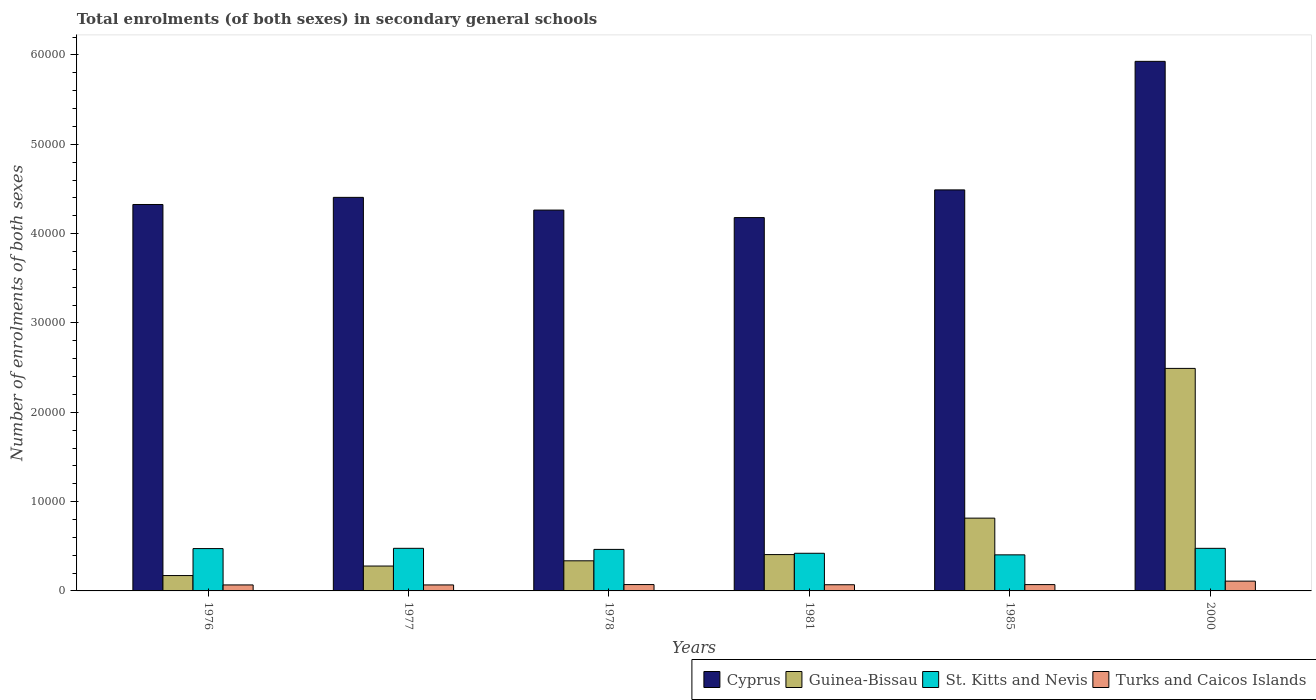How many different coloured bars are there?
Make the answer very short. 4. Are the number of bars per tick equal to the number of legend labels?
Offer a very short reply. Yes. What is the number of enrolments in secondary schools in Guinea-Bissau in 1978?
Make the answer very short. 3371. Across all years, what is the maximum number of enrolments in secondary schools in Turks and Caicos Islands?
Your answer should be very brief. 1095. Across all years, what is the minimum number of enrolments in secondary schools in Cyprus?
Offer a terse response. 4.18e+04. In which year was the number of enrolments in secondary schools in Guinea-Bissau maximum?
Your response must be concise. 2000. In which year was the number of enrolments in secondary schools in Guinea-Bissau minimum?
Provide a succinct answer. 1976. What is the total number of enrolments in secondary schools in Cyprus in the graph?
Offer a very short reply. 2.76e+05. What is the difference between the number of enrolments in secondary schools in St. Kitts and Nevis in 1981 and that in 1985?
Make the answer very short. 176. What is the difference between the number of enrolments in secondary schools in Turks and Caicos Islands in 1976 and the number of enrolments in secondary schools in Guinea-Bissau in 1978?
Make the answer very short. -2700. What is the average number of enrolments in secondary schools in St. Kitts and Nevis per year?
Ensure brevity in your answer.  4529.83. In the year 1977, what is the difference between the number of enrolments in secondary schools in Guinea-Bissau and number of enrolments in secondary schools in St. Kitts and Nevis?
Your answer should be very brief. -1985. What is the ratio of the number of enrolments in secondary schools in St. Kitts and Nevis in 1977 to that in 1981?
Your answer should be very brief. 1.13. What is the difference between the highest and the lowest number of enrolments in secondary schools in Turks and Caicos Islands?
Make the answer very short. 424. In how many years, is the number of enrolments in secondary schools in Guinea-Bissau greater than the average number of enrolments in secondary schools in Guinea-Bissau taken over all years?
Make the answer very short. 2. Is the sum of the number of enrolments in secondary schools in Turks and Caicos Islands in 1976 and 1977 greater than the maximum number of enrolments in secondary schools in St. Kitts and Nevis across all years?
Your answer should be compact. No. What does the 4th bar from the left in 1976 represents?
Your response must be concise. Turks and Caicos Islands. What does the 2nd bar from the right in 1978 represents?
Make the answer very short. St. Kitts and Nevis. What is the difference between two consecutive major ticks on the Y-axis?
Offer a terse response. 10000. Are the values on the major ticks of Y-axis written in scientific E-notation?
Give a very brief answer. No. Does the graph contain any zero values?
Offer a very short reply. No. Where does the legend appear in the graph?
Provide a short and direct response. Bottom right. How many legend labels are there?
Offer a terse response. 4. What is the title of the graph?
Your response must be concise. Total enrolments (of both sexes) in secondary general schools. Does "Turkmenistan" appear as one of the legend labels in the graph?
Provide a short and direct response. No. What is the label or title of the Y-axis?
Ensure brevity in your answer.  Number of enrolments of both sexes. What is the Number of enrolments of both sexes of Cyprus in 1976?
Offer a terse response. 4.33e+04. What is the Number of enrolments of both sexes of Guinea-Bissau in 1976?
Your response must be concise. 1720. What is the Number of enrolments of both sexes of St. Kitts and Nevis in 1976?
Offer a terse response. 4740. What is the Number of enrolments of both sexes in Turks and Caicos Islands in 1976?
Ensure brevity in your answer.  671. What is the Number of enrolments of both sexes of Cyprus in 1977?
Your answer should be very brief. 4.41e+04. What is the Number of enrolments of both sexes in Guinea-Bissau in 1977?
Provide a short and direct response. 2785. What is the Number of enrolments of both sexes in St. Kitts and Nevis in 1977?
Ensure brevity in your answer.  4770. What is the Number of enrolments of both sexes of Turks and Caicos Islands in 1977?
Your response must be concise. 671. What is the Number of enrolments of both sexes in Cyprus in 1978?
Ensure brevity in your answer.  4.26e+04. What is the Number of enrolments of both sexes of Guinea-Bissau in 1978?
Offer a terse response. 3371. What is the Number of enrolments of both sexes of St. Kitts and Nevis in 1978?
Ensure brevity in your answer.  4649. What is the Number of enrolments of both sexes of Turks and Caicos Islands in 1978?
Keep it short and to the point. 711. What is the Number of enrolments of both sexes of Cyprus in 1981?
Offer a very short reply. 4.18e+04. What is the Number of enrolments of both sexes in Guinea-Bissau in 1981?
Ensure brevity in your answer.  4068. What is the Number of enrolments of both sexes in St. Kitts and Nevis in 1981?
Your response must be concise. 4214. What is the Number of enrolments of both sexes in Turks and Caicos Islands in 1981?
Make the answer very short. 691. What is the Number of enrolments of both sexes in Cyprus in 1985?
Offer a very short reply. 4.49e+04. What is the Number of enrolments of both sexes in Guinea-Bissau in 1985?
Give a very brief answer. 8149. What is the Number of enrolments of both sexes in St. Kitts and Nevis in 1985?
Provide a succinct answer. 4038. What is the Number of enrolments of both sexes of Turks and Caicos Islands in 1985?
Your response must be concise. 707. What is the Number of enrolments of both sexes in Cyprus in 2000?
Your answer should be compact. 5.93e+04. What is the Number of enrolments of both sexes of Guinea-Bissau in 2000?
Keep it short and to the point. 2.49e+04. What is the Number of enrolments of both sexes of St. Kitts and Nevis in 2000?
Your answer should be compact. 4768. What is the Number of enrolments of both sexes in Turks and Caicos Islands in 2000?
Give a very brief answer. 1095. Across all years, what is the maximum Number of enrolments of both sexes of Cyprus?
Give a very brief answer. 5.93e+04. Across all years, what is the maximum Number of enrolments of both sexes of Guinea-Bissau?
Your answer should be compact. 2.49e+04. Across all years, what is the maximum Number of enrolments of both sexes in St. Kitts and Nevis?
Offer a very short reply. 4770. Across all years, what is the maximum Number of enrolments of both sexes of Turks and Caicos Islands?
Provide a succinct answer. 1095. Across all years, what is the minimum Number of enrolments of both sexes in Cyprus?
Your answer should be very brief. 4.18e+04. Across all years, what is the minimum Number of enrolments of both sexes of Guinea-Bissau?
Your response must be concise. 1720. Across all years, what is the minimum Number of enrolments of both sexes in St. Kitts and Nevis?
Offer a terse response. 4038. Across all years, what is the minimum Number of enrolments of both sexes of Turks and Caicos Islands?
Offer a very short reply. 671. What is the total Number of enrolments of both sexes of Cyprus in the graph?
Make the answer very short. 2.76e+05. What is the total Number of enrolments of both sexes of Guinea-Bissau in the graph?
Your response must be concise. 4.50e+04. What is the total Number of enrolments of both sexes of St. Kitts and Nevis in the graph?
Your response must be concise. 2.72e+04. What is the total Number of enrolments of both sexes of Turks and Caicos Islands in the graph?
Provide a succinct answer. 4546. What is the difference between the Number of enrolments of both sexes of Cyprus in 1976 and that in 1977?
Offer a very short reply. -798. What is the difference between the Number of enrolments of both sexes of Guinea-Bissau in 1976 and that in 1977?
Give a very brief answer. -1065. What is the difference between the Number of enrolments of both sexes in Turks and Caicos Islands in 1976 and that in 1977?
Give a very brief answer. 0. What is the difference between the Number of enrolments of both sexes in Cyprus in 1976 and that in 1978?
Ensure brevity in your answer.  626. What is the difference between the Number of enrolments of both sexes in Guinea-Bissau in 1976 and that in 1978?
Provide a short and direct response. -1651. What is the difference between the Number of enrolments of both sexes of St. Kitts and Nevis in 1976 and that in 1978?
Your answer should be very brief. 91. What is the difference between the Number of enrolments of both sexes of Cyprus in 1976 and that in 1981?
Offer a terse response. 1467. What is the difference between the Number of enrolments of both sexes in Guinea-Bissau in 1976 and that in 1981?
Give a very brief answer. -2348. What is the difference between the Number of enrolments of both sexes of St. Kitts and Nevis in 1976 and that in 1981?
Make the answer very short. 526. What is the difference between the Number of enrolments of both sexes of Turks and Caicos Islands in 1976 and that in 1981?
Keep it short and to the point. -20. What is the difference between the Number of enrolments of both sexes of Cyprus in 1976 and that in 1985?
Your answer should be very brief. -1634. What is the difference between the Number of enrolments of both sexes of Guinea-Bissau in 1976 and that in 1985?
Your response must be concise. -6429. What is the difference between the Number of enrolments of both sexes of St. Kitts and Nevis in 1976 and that in 1985?
Provide a succinct answer. 702. What is the difference between the Number of enrolments of both sexes of Turks and Caicos Islands in 1976 and that in 1985?
Provide a short and direct response. -36. What is the difference between the Number of enrolments of both sexes in Cyprus in 1976 and that in 2000?
Provide a short and direct response. -1.60e+04. What is the difference between the Number of enrolments of both sexes of Guinea-Bissau in 1976 and that in 2000?
Offer a terse response. -2.32e+04. What is the difference between the Number of enrolments of both sexes of St. Kitts and Nevis in 1976 and that in 2000?
Ensure brevity in your answer.  -28. What is the difference between the Number of enrolments of both sexes in Turks and Caicos Islands in 1976 and that in 2000?
Provide a succinct answer. -424. What is the difference between the Number of enrolments of both sexes in Cyprus in 1977 and that in 1978?
Ensure brevity in your answer.  1424. What is the difference between the Number of enrolments of both sexes in Guinea-Bissau in 1977 and that in 1978?
Your answer should be very brief. -586. What is the difference between the Number of enrolments of both sexes of St. Kitts and Nevis in 1977 and that in 1978?
Provide a short and direct response. 121. What is the difference between the Number of enrolments of both sexes of Cyprus in 1977 and that in 1981?
Your answer should be very brief. 2265. What is the difference between the Number of enrolments of both sexes of Guinea-Bissau in 1977 and that in 1981?
Your answer should be compact. -1283. What is the difference between the Number of enrolments of both sexes of St. Kitts and Nevis in 1977 and that in 1981?
Offer a very short reply. 556. What is the difference between the Number of enrolments of both sexes in Turks and Caicos Islands in 1977 and that in 1981?
Your answer should be very brief. -20. What is the difference between the Number of enrolments of both sexes in Cyprus in 1977 and that in 1985?
Make the answer very short. -836. What is the difference between the Number of enrolments of both sexes in Guinea-Bissau in 1977 and that in 1985?
Your answer should be compact. -5364. What is the difference between the Number of enrolments of both sexes of St. Kitts and Nevis in 1977 and that in 1985?
Provide a succinct answer. 732. What is the difference between the Number of enrolments of both sexes of Turks and Caicos Islands in 1977 and that in 1985?
Keep it short and to the point. -36. What is the difference between the Number of enrolments of both sexes in Cyprus in 1977 and that in 2000?
Your response must be concise. -1.52e+04. What is the difference between the Number of enrolments of both sexes in Guinea-Bissau in 1977 and that in 2000?
Offer a very short reply. -2.21e+04. What is the difference between the Number of enrolments of both sexes of Turks and Caicos Islands in 1977 and that in 2000?
Ensure brevity in your answer.  -424. What is the difference between the Number of enrolments of both sexes in Cyprus in 1978 and that in 1981?
Your answer should be compact. 841. What is the difference between the Number of enrolments of both sexes of Guinea-Bissau in 1978 and that in 1981?
Your response must be concise. -697. What is the difference between the Number of enrolments of both sexes in St. Kitts and Nevis in 1978 and that in 1981?
Ensure brevity in your answer.  435. What is the difference between the Number of enrolments of both sexes of Turks and Caicos Islands in 1978 and that in 1981?
Your response must be concise. 20. What is the difference between the Number of enrolments of both sexes of Cyprus in 1978 and that in 1985?
Give a very brief answer. -2260. What is the difference between the Number of enrolments of both sexes in Guinea-Bissau in 1978 and that in 1985?
Offer a terse response. -4778. What is the difference between the Number of enrolments of both sexes in St. Kitts and Nevis in 1978 and that in 1985?
Provide a short and direct response. 611. What is the difference between the Number of enrolments of both sexes of Turks and Caicos Islands in 1978 and that in 1985?
Offer a terse response. 4. What is the difference between the Number of enrolments of both sexes in Cyprus in 1978 and that in 2000?
Provide a short and direct response. -1.66e+04. What is the difference between the Number of enrolments of both sexes in Guinea-Bissau in 1978 and that in 2000?
Keep it short and to the point. -2.15e+04. What is the difference between the Number of enrolments of both sexes in St. Kitts and Nevis in 1978 and that in 2000?
Give a very brief answer. -119. What is the difference between the Number of enrolments of both sexes in Turks and Caicos Islands in 1978 and that in 2000?
Offer a terse response. -384. What is the difference between the Number of enrolments of both sexes of Cyprus in 1981 and that in 1985?
Offer a very short reply. -3101. What is the difference between the Number of enrolments of both sexes in Guinea-Bissau in 1981 and that in 1985?
Make the answer very short. -4081. What is the difference between the Number of enrolments of both sexes in St. Kitts and Nevis in 1981 and that in 1985?
Your answer should be compact. 176. What is the difference between the Number of enrolments of both sexes in Cyprus in 1981 and that in 2000?
Keep it short and to the point. -1.75e+04. What is the difference between the Number of enrolments of both sexes of Guinea-Bissau in 1981 and that in 2000?
Your response must be concise. -2.08e+04. What is the difference between the Number of enrolments of both sexes in St. Kitts and Nevis in 1981 and that in 2000?
Ensure brevity in your answer.  -554. What is the difference between the Number of enrolments of both sexes in Turks and Caicos Islands in 1981 and that in 2000?
Ensure brevity in your answer.  -404. What is the difference between the Number of enrolments of both sexes of Cyprus in 1985 and that in 2000?
Keep it short and to the point. -1.44e+04. What is the difference between the Number of enrolments of both sexes of Guinea-Bissau in 1985 and that in 2000?
Your response must be concise. -1.68e+04. What is the difference between the Number of enrolments of both sexes of St. Kitts and Nevis in 1985 and that in 2000?
Keep it short and to the point. -730. What is the difference between the Number of enrolments of both sexes in Turks and Caicos Islands in 1985 and that in 2000?
Ensure brevity in your answer.  -388. What is the difference between the Number of enrolments of both sexes of Cyprus in 1976 and the Number of enrolments of both sexes of Guinea-Bissau in 1977?
Offer a very short reply. 4.05e+04. What is the difference between the Number of enrolments of both sexes in Cyprus in 1976 and the Number of enrolments of both sexes in St. Kitts and Nevis in 1977?
Give a very brief answer. 3.85e+04. What is the difference between the Number of enrolments of both sexes in Cyprus in 1976 and the Number of enrolments of both sexes in Turks and Caicos Islands in 1977?
Your answer should be very brief. 4.26e+04. What is the difference between the Number of enrolments of both sexes of Guinea-Bissau in 1976 and the Number of enrolments of both sexes of St. Kitts and Nevis in 1977?
Your response must be concise. -3050. What is the difference between the Number of enrolments of both sexes of Guinea-Bissau in 1976 and the Number of enrolments of both sexes of Turks and Caicos Islands in 1977?
Keep it short and to the point. 1049. What is the difference between the Number of enrolments of both sexes of St. Kitts and Nevis in 1976 and the Number of enrolments of both sexes of Turks and Caicos Islands in 1977?
Your response must be concise. 4069. What is the difference between the Number of enrolments of both sexes in Cyprus in 1976 and the Number of enrolments of both sexes in Guinea-Bissau in 1978?
Offer a very short reply. 3.99e+04. What is the difference between the Number of enrolments of both sexes of Cyprus in 1976 and the Number of enrolments of both sexes of St. Kitts and Nevis in 1978?
Provide a succinct answer. 3.86e+04. What is the difference between the Number of enrolments of both sexes of Cyprus in 1976 and the Number of enrolments of both sexes of Turks and Caicos Islands in 1978?
Offer a terse response. 4.26e+04. What is the difference between the Number of enrolments of both sexes of Guinea-Bissau in 1976 and the Number of enrolments of both sexes of St. Kitts and Nevis in 1978?
Offer a terse response. -2929. What is the difference between the Number of enrolments of both sexes in Guinea-Bissau in 1976 and the Number of enrolments of both sexes in Turks and Caicos Islands in 1978?
Keep it short and to the point. 1009. What is the difference between the Number of enrolments of both sexes of St. Kitts and Nevis in 1976 and the Number of enrolments of both sexes of Turks and Caicos Islands in 1978?
Make the answer very short. 4029. What is the difference between the Number of enrolments of both sexes in Cyprus in 1976 and the Number of enrolments of both sexes in Guinea-Bissau in 1981?
Ensure brevity in your answer.  3.92e+04. What is the difference between the Number of enrolments of both sexes in Cyprus in 1976 and the Number of enrolments of both sexes in St. Kitts and Nevis in 1981?
Give a very brief answer. 3.90e+04. What is the difference between the Number of enrolments of both sexes in Cyprus in 1976 and the Number of enrolments of both sexes in Turks and Caicos Islands in 1981?
Give a very brief answer. 4.26e+04. What is the difference between the Number of enrolments of both sexes of Guinea-Bissau in 1976 and the Number of enrolments of both sexes of St. Kitts and Nevis in 1981?
Offer a very short reply. -2494. What is the difference between the Number of enrolments of both sexes in Guinea-Bissau in 1976 and the Number of enrolments of both sexes in Turks and Caicos Islands in 1981?
Ensure brevity in your answer.  1029. What is the difference between the Number of enrolments of both sexes of St. Kitts and Nevis in 1976 and the Number of enrolments of both sexes of Turks and Caicos Islands in 1981?
Keep it short and to the point. 4049. What is the difference between the Number of enrolments of both sexes of Cyprus in 1976 and the Number of enrolments of both sexes of Guinea-Bissau in 1985?
Your response must be concise. 3.51e+04. What is the difference between the Number of enrolments of both sexes of Cyprus in 1976 and the Number of enrolments of both sexes of St. Kitts and Nevis in 1985?
Keep it short and to the point. 3.92e+04. What is the difference between the Number of enrolments of both sexes in Cyprus in 1976 and the Number of enrolments of both sexes in Turks and Caicos Islands in 1985?
Give a very brief answer. 4.26e+04. What is the difference between the Number of enrolments of both sexes in Guinea-Bissau in 1976 and the Number of enrolments of both sexes in St. Kitts and Nevis in 1985?
Offer a terse response. -2318. What is the difference between the Number of enrolments of both sexes of Guinea-Bissau in 1976 and the Number of enrolments of both sexes of Turks and Caicos Islands in 1985?
Provide a succinct answer. 1013. What is the difference between the Number of enrolments of both sexes of St. Kitts and Nevis in 1976 and the Number of enrolments of both sexes of Turks and Caicos Islands in 1985?
Keep it short and to the point. 4033. What is the difference between the Number of enrolments of both sexes in Cyprus in 1976 and the Number of enrolments of both sexes in Guinea-Bissau in 2000?
Your response must be concise. 1.84e+04. What is the difference between the Number of enrolments of both sexes in Cyprus in 1976 and the Number of enrolments of both sexes in St. Kitts and Nevis in 2000?
Your answer should be compact. 3.85e+04. What is the difference between the Number of enrolments of both sexes in Cyprus in 1976 and the Number of enrolments of both sexes in Turks and Caicos Islands in 2000?
Provide a succinct answer. 4.22e+04. What is the difference between the Number of enrolments of both sexes in Guinea-Bissau in 1976 and the Number of enrolments of both sexes in St. Kitts and Nevis in 2000?
Provide a short and direct response. -3048. What is the difference between the Number of enrolments of both sexes of Guinea-Bissau in 1976 and the Number of enrolments of both sexes of Turks and Caicos Islands in 2000?
Give a very brief answer. 625. What is the difference between the Number of enrolments of both sexes in St. Kitts and Nevis in 1976 and the Number of enrolments of both sexes in Turks and Caicos Islands in 2000?
Offer a very short reply. 3645. What is the difference between the Number of enrolments of both sexes in Cyprus in 1977 and the Number of enrolments of both sexes in Guinea-Bissau in 1978?
Provide a short and direct response. 4.07e+04. What is the difference between the Number of enrolments of both sexes of Cyprus in 1977 and the Number of enrolments of both sexes of St. Kitts and Nevis in 1978?
Ensure brevity in your answer.  3.94e+04. What is the difference between the Number of enrolments of both sexes in Cyprus in 1977 and the Number of enrolments of both sexes in Turks and Caicos Islands in 1978?
Offer a very short reply. 4.33e+04. What is the difference between the Number of enrolments of both sexes in Guinea-Bissau in 1977 and the Number of enrolments of both sexes in St. Kitts and Nevis in 1978?
Your answer should be very brief. -1864. What is the difference between the Number of enrolments of both sexes in Guinea-Bissau in 1977 and the Number of enrolments of both sexes in Turks and Caicos Islands in 1978?
Offer a very short reply. 2074. What is the difference between the Number of enrolments of both sexes in St. Kitts and Nevis in 1977 and the Number of enrolments of both sexes in Turks and Caicos Islands in 1978?
Provide a succinct answer. 4059. What is the difference between the Number of enrolments of both sexes in Cyprus in 1977 and the Number of enrolments of both sexes in Guinea-Bissau in 1981?
Your answer should be very brief. 4.00e+04. What is the difference between the Number of enrolments of both sexes in Cyprus in 1977 and the Number of enrolments of both sexes in St. Kitts and Nevis in 1981?
Provide a short and direct response. 3.98e+04. What is the difference between the Number of enrolments of both sexes of Cyprus in 1977 and the Number of enrolments of both sexes of Turks and Caicos Islands in 1981?
Provide a succinct answer. 4.34e+04. What is the difference between the Number of enrolments of both sexes in Guinea-Bissau in 1977 and the Number of enrolments of both sexes in St. Kitts and Nevis in 1981?
Ensure brevity in your answer.  -1429. What is the difference between the Number of enrolments of both sexes of Guinea-Bissau in 1977 and the Number of enrolments of both sexes of Turks and Caicos Islands in 1981?
Provide a short and direct response. 2094. What is the difference between the Number of enrolments of both sexes of St. Kitts and Nevis in 1977 and the Number of enrolments of both sexes of Turks and Caicos Islands in 1981?
Ensure brevity in your answer.  4079. What is the difference between the Number of enrolments of both sexes in Cyprus in 1977 and the Number of enrolments of both sexes in Guinea-Bissau in 1985?
Offer a terse response. 3.59e+04. What is the difference between the Number of enrolments of both sexes in Cyprus in 1977 and the Number of enrolments of both sexes in St. Kitts and Nevis in 1985?
Ensure brevity in your answer.  4.00e+04. What is the difference between the Number of enrolments of both sexes in Cyprus in 1977 and the Number of enrolments of both sexes in Turks and Caicos Islands in 1985?
Your answer should be compact. 4.34e+04. What is the difference between the Number of enrolments of both sexes in Guinea-Bissau in 1977 and the Number of enrolments of both sexes in St. Kitts and Nevis in 1985?
Offer a terse response. -1253. What is the difference between the Number of enrolments of both sexes in Guinea-Bissau in 1977 and the Number of enrolments of both sexes in Turks and Caicos Islands in 1985?
Offer a very short reply. 2078. What is the difference between the Number of enrolments of both sexes in St. Kitts and Nevis in 1977 and the Number of enrolments of both sexes in Turks and Caicos Islands in 1985?
Ensure brevity in your answer.  4063. What is the difference between the Number of enrolments of both sexes of Cyprus in 1977 and the Number of enrolments of both sexes of Guinea-Bissau in 2000?
Give a very brief answer. 1.91e+04. What is the difference between the Number of enrolments of both sexes in Cyprus in 1977 and the Number of enrolments of both sexes in St. Kitts and Nevis in 2000?
Your answer should be compact. 3.93e+04. What is the difference between the Number of enrolments of both sexes in Cyprus in 1977 and the Number of enrolments of both sexes in Turks and Caicos Islands in 2000?
Your answer should be very brief. 4.30e+04. What is the difference between the Number of enrolments of both sexes in Guinea-Bissau in 1977 and the Number of enrolments of both sexes in St. Kitts and Nevis in 2000?
Ensure brevity in your answer.  -1983. What is the difference between the Number of enrolments of both sexes in Guinea-Bissau in 1977 and the Number of enrolments of both sexes in Turks and Caicos Islands in 2000?
Your answer should be very brief. 1690. What is the difference between the Number of enrolments of both sexes of St. Kitts and Nevis in 1977 and the Number of enrolments of both sexes of Turks and Caicos Islands in 2000?
Provide a short and direct response. 3675. What is the difference between the Number of enrolments of both sexes of Cyprus in 1978 and the Number of enrolments of both sexes of Guinea-Bissau in 1981?
Offer a very short reply. 3.86e+04. What is the difference between the Number of enrolments of both sexes in Cyprus in 1978 and the Number of enrolments of both sexes in St. Kitts and Nevis in 1981?
Give a very brief answer. 3.84e+04. What is the difference between the Number of enrolments of both sexes of Cyprus in 1978 and the Number of enrolments of both sexes of Turks and Caicos Islands in 1981?
Offer a terse response. 4.19e+04. What is the difference between the Number of enrolments of both sexes of Guinea-Bissau in 1978 and the Number of enrolments of both sexes of St. Kitts and Nevis in 1981?
Make the answer very short. -843. What is the difference between the Number of enrolments of both sexes of Guinea-Bissau in 1978 and the Number of enrolments of both sexes of Turks and Caicos Islands in 1981?
Your response must be concise. 2680. What is the difference between the Number of enrolments of both sexes in St. Kitts and Nevis in 1978 and the Number of enrolments of both sexes in Turks and Caicos Islands in 1981?
Provide a succinct answer. 3958. What is the difference between the Number of enrolments of both sexes in Cyprus in 1978 and the Number of enrolments of both sexes in Guinea-Bissau in 1985?
Give a very brief answer. 3.45e+04. What is the difference between the Number of enrolments of both sexes in Cyprus in 1978 and the Number of enrolments of both sexes in St. Kitts and Nevis in 1985?
Provide a short and direct response. 3.86e+04. What is the difference between the Number of enrolments of both sexes of Cyprus in 1978 and the Number of enrolments of both sexes of Turks and Caicos Islands in 1985?
Provide a short and direct response. 4.19e+04. What is the difference between the Number of enrolments of both sexes in Guinea-Bissau in 1978 and the Number of enrolments of both sexes in St. Kitts and Nevis in 1985?
Offer a very short reply. -667. What is the difference between the Number of enrolments of both sexes in Guinea-Bissau in 1978 and the Number of enrolments of both sexes in Turks and Caicos Islands in 1985?
Ensure brevity in your answer.  2664. What is the difference between the Number of enrolments of both sexes of St. Kitts and Nevis in 1978 and the Number of enrolments of both sexes of Turks and Caicos Islands in 1985?
Provide a succinct answer. 3942. What is the difference between the Number of enrolments of both sexes in Cyprus in 1978 and the Number of enrolments of both sexes in Guinea-Bissau in 2000?
Make the answer very short. 1.77e+04. What is the difference between the Number of enrolments of both sexes of Cyprus in 1978 and the Number of enrolments of both sexes of St. Kitts and Nevis in 2000?
Give a very brief answer. 3.79e+04. What is the difference between the Number of enrolments of both sexes of Cyprus in 1978 and the Number of enrolments of both sexes of Turks and Caicos Islands in 2000?
Ensure brevity in your answer.  4.15e+04. What is the difference between the Number of enrolments of both sexes of Guinea-Bissau in 1978 and the Number of enrolments of both sexes of St. Kitts and Nevis in 2000?
Offer a very short reply. -1397. What is the difference between the Number of enrolments of both sexes in Guinea-Bissau in 1978 and the Number of enrolments of both sexes in Turks and Caicos Islands in 2000?
Give a very brief answer. 2276. What is the difference between the Number of enrolments of both sexes in St. Kitts and Nevis in 1978 and the Number of enrolments of both sexes in Turks and Caicos Islands in 2000?
Keep it short and to the point. 3554. What is the difference between the Number of enrolments of both sexes of Cyprus in 1981 and the Number of enrolments of both sexes of Guinea-Bissau in 1985?
Provide a succinct answer. 3.36e+04. What is the difference between the Number of enrolments of both sexes of Cyprus in 1981 and the Number of enrolments of both sexes of St. Kitts and Nevis in 1985?
Your answer should be compact. 3.78e+04. What is the difference between the Number of enrolments of both sexes in Cyprus in 1981 and the Number of enrolments of both sexes in Turks and Caicos Islands in 1985?
Your answer should be very brief. 4.11e+04. What is the difference between the Number of enrolments of both sexes of Guinea-Bissau in 1981 and the Number of enrolments of both sexes of Turks and Caicos Islands in 1985?
Ensure brevity in your answer.  3361. What is the difference between the Number of enrolments of both sexes of St. Kitts and Nevis in 1981 and the Number of enrolments of both sexes of Turks and Caicos Islands in 1985?
Give a very brief answer. 3507. What is the difference between the Number of enrolments of both sexes in Cyprus in 1981 and the Number of enrolments of both sexes in Guinea-Bissau in 2000?
Provide a short and direct response. 1.69e+04. What is the difference between the Number of enrolments of both sexes of Cyprus in 1981 and the Number of enrolments of both sexes of St. Kitts and Nevis in 2000?
Offer a very short reply. 3.70e+04. What is the difference between the Number of enrolments of both sexes of Cyprus in 1981 and the Number of enrolments of both sexes of Turks and Caicos Islands in 2000?
Offer a terse response. 4.07e+04. What is the difference between the Number of enrolments of both sexes in Guinea-Bissau in 1981 and the Number of enrolments of both sexes in St. Kitts and Nevis in 2000?
Ensure brevity in your answer.  -700. What is the difference between the Number of enrolments of both sexes in Guinea-Bissau in 1981 and the Number of enrolments of both sexes in Turks and Caicos Islands in 2000?
Your answer should be very brief. 2973. What is the difference between the Number of enrolments of both sexes in St. Kitts and Nevis in 1981 and the Number of enrolments of both sexes in Turks and Caicos Islands in 2000?
Your answer should be very brief. 3119. What is the difference between the Number of enrolments of both sexes of Cyprus in 1985 and the Number of enrolments of both sexes of Guinea-Bissau in 2000?
Keep it short and to the point. 2.00e+04. What is the difference between the Number of enrolments of both sexes in Cyprus in 1985 and the Number of enrolments of both sexes in St. Kitts and Nevis in 2000?
Your response must be concise. 4.01e+04. What is the difference between the Number of enrolments of both sexes in Cyprus in 1985 and the Number of enrolments of both sexes in Turks and Caicos Islands in 2000?
Provide a short and direct response. 4.38e+04. What is the difference between the Number of enrolments of both sexes in Guinea-Bissau in 1985 and the Number of enrolments of both sexes in St. Kitts and Nevis in 2000?
Offer a very short reply. 3381. What is the difference between the Number of enrolments of both sexes of Guinea-Bissau in 1985 and the Number of enrolments of both sexes of Turks and Caicos Islands in 2000?
Provide a short and direct response. 7054. What is the difference between the Number of enrolments of both sexes in St. Kitts and Nevis in 1985 and the Number of enrolments of both sexes in Turks and Caicos Islands in 2000?
Your answer should be very brief. 2943. What is the average Number of enrolments of both sexes of Cyprus per year?
Make the answer very short. 4.60e+04. What is the average Number of enrolments of both sexes in Guinea-Bissau per year?
Ensure brevity in your answer.  7500.67. What is the average Number of enrolments of both sexes of St. Kitts and Nevis per year?
Make the answer very short. 4529.83. What is the average Number of enrolments of both sexes in Turks and Caicos Islands per year?
Your answer should be very brief. 757.67. In the year 1976, what is the difference between the Number of enrolments of both sexes of Cyprus and Number of enrolments of both sexes of Guinea-Bissau?
Offer a very short reply. 4.15e+04. In the year 1976, what is the difference between the Number of enrolments of both sexes in Cyprus and Number of enrolments of both sexes in St. Kitts and Nevis?
Ensure brevity in your answer.  3.85e+04. In the year 1976, what is the difference between the Number of enrolments of both sexes in Cyprus and Number of enrolments of both sexes in Turks and Caicos Islands?
Keep it short and to the point. 4.26e+04. In the year 1976, what is the difference between the Number of enrolments of both sexes in Guinea-Bissau and Number of enrolments of both sexes in St. Kitts and Nevis?
Provide a succinct answer. -3020. In the year 1976, what is the difference between the Number of enrolments of both sexes of Guinea-Bissau and Number of enrolments of both sexes of Turks and Caicos Islands?
Provide a succinct answer. 1049. In the year 1976, what is the difference between the Number of enrolments of both sexes of St. Kitts and Nevis and Number of enrolments of both sexes of Turks and Caicos Islands?
Provide a succinct answer. 4069. In the year 1977, what is the difference between the Number of enrolments of both sexes in Cyprus and Number of enrolments of both sexes in Guinea-Bissau?
Provide a succinct answer. 4.13e+04. In the year 1977, what is the difference between the Number of enrolments of both sexes of Cyprus and Number of enrolments of both sexes of St. Kitts and Nevis?
Keep it short and to the point. 3.93e+04. In the year 1977, what is the difference between the Number of enrolments of both sexes in Cyprus and Number of enrolments of both sexes in Turks and Caicos Islands?
Make the answer very short. 4.34e+04. In the year 1977, what is the difference between the Number of enrolments of both sexes in Guinea-Bissau and Number of enrolments of both sexes in St. Kitts and Nevis?
Provide a short and direct response. -1985. In the year 1977, what is the difference between the Number of enrolments of both sexes in Guinea-Bissau and Number of enrolments of both sexes in Turks and Caicos Islands?
Offer a very short reply. 2114. In the year 1977, what is the difference between the Number of enrolments of both sexes of St. Kitts and Nevis and Number of enrolments of both sexes of Turks and Caicos Islands?
Your response must be concise. 4099. In the year 1978, what is the difference between the Number of enrolments of both sexes of Cyprus and Number of enrolments of both sexes of Guinea-Bissau?
Provide a short and direct response. 3.93e+04. In the year 1978, what is the difference between the Number of enrolments of both sexes of Cyprus and Number of enrolments of both sexes of St. Kitts and Nevis?
Give a very brief answer. 3.80e+04. In the year 1978, what is the difference between the Number of enrolments of both sexes of Cyprus and Number of enrolments of both sexes of Turks and Caicos Islands?
Keep it short and to the point. 4.19e+04. In the year 1978, what is the difference between the Number of enrolments of both sexes of Guinea-Bissau and Number of enrolments of both sexes of St. Kitts and Nevis?
Offer a terse response. -1278. In the year 1978, what is the difference between the Number of enrolments of both sexes of Guinea-Bissau and Number of enrolments of both sexes of Turks and Caicos Islands?
Offer a terse response. 2660. In the year 1978, what is the difference between the Number of enrolments of both sexes of St. Kitts and Nevis and Number of enrolments of both sexes of Turks and Caicos Islands?
Offer a very short reply. 3938. In the year 1981, what is the difference between the Number of enrolments of both sexes of Cyprus and Number of enrolments of both sexes of Guinea-Bissau?
Make the answer very short. 3.77e+04. In the year 1981, what is the difference between the Number of enrolments of both sexes of Cyprus and Number of enrolments of both sexes of St. Kitts and Nevis?
Provide a short and direct response. 3.76e+04. In the year 1981, what is the difference between the Number of enrolments of both sexes in Cyprus and Number of enrolments of both sexes in Turks and Caicos Islands?
Keep it short and to the point. 4.11e+04. In the year 1981, what is the difference between the Number of enrolments of both sexes of Guinea-Bissau and Number of enrolments of both sexes of St. Kitts and Nevis?
Provide a short and direct response. -146. In the year 1981, what is the difference between the Number of enrolments of both sexes of Guinea-Bissau and Number of enrolments of both sexes of Turks and Caicos Islands?
Make the answer very short. 3377. In the year 1981, what is the difference between the Number of enrolments of both sexes in St. Kitts and Nevis and Number of enrolments of both sexes in Turks and Caicos Islands?
Your response must be concise. 3523. In the year 1985, what is the difference between the Number of enrolments of both sexes in Cyprus and Number of enrolments of both sexes in Guinea-Bissau?
Keep it short and to the point. 3.67e+04. In the year 1985, what is the difference between the Number of enrolments of both sexes of Cyprus and Number of enrolments of both sexes of St. Kitts and Nevis?
Offer a very short reply. 4.09e+04. In the year 1985, what is the difference between the Number of enrolments of both sexes of Cyprus and Number of enrolments of both sexes of Turks and Caicos Islands?
Offer a very short reply. 4.42e+04. In the year 1985, what is the difference between the Number of enrolments of both sexes in Guinea-Bissau and Number of enrolments of both sexes in St. Kitts and Nevis?
Your answer should be very brief. 4111. In the year 1985, what is the difference between the Number of enrolments of both sexes in Guinea-Bissau and Number of enrolments of both sexes in Turks and Caicos Islands?
Keep it short and to the point. 7442. In the year 1985, what is the difference between the Number of enrolments of both sexes of St. Kitts and Nevis and Number of enrolments of both sexes of Turks and Caicos Islands?
Provide a short and direct response. 3331. In the year 2000, what is the difference between the Number of enrolments of both sexes in Cyprus and Number of enrolments of both sexes in Guinea-Bissau?
Ensure brevity in your answer.  3.44e+04. In the year 2000, what is the difference between the Number of enrolments of both sexes of Cyprus and Number of enrolments of both sexes of St. Kitts and Nevis?
Offer a terse response. 5.45e+04. In the year 2000, what is the difference between the Number of enrolments of both sexes of Cyprus and Number of enrolments of both sexes of Turks and Caicos Islands?
Provide a succinct answer. 5.82e+04. In the year 2000, what is the difference between the Number of enrolments of both sexes in Guinea-Bissau and Number of enrolments of both sexes in St. Kitts and Nevis?
Your response must be concise. 2.01e+04. In the year 2000, what is the difference between the Number of enrolments of both sexes of Guinea-Bissau and Number of enrolments of both sexes of Turks and Caicos Islands?
Make the answer very short. 2.38e+04. In the year 2000, what is the difference between the Number of enrolments of both sexes of St. Kitts and Nevis and Number of enrolments of both sexes of Turks and Caicos Islands?
Keep it short and to the point. 3673. What is the ratio of the Number of enrolments of both sexes in Cyprus in 1976 to that in 1977?
Keep it short and to the point. 0.98. What is the ratio of the Number of enrolments of both sexes in Guinea-Bissau in 1976 to that in 1977?
Ensure brevity in your answer.  0.62. What is the ratio of the Number of enrolments of both sexes in Turks and Caicos Islands in 1976 to that in 1977?
Your response must be concise. 1. What is the ratio of the Number of enrolments of both sexes in Cyprus in 1976 to that in 1978?
Provide a short and direct response. 1.01. What is the ratio of the Number of enrolments of both sexes in Guinea-Bissau in 1976 to that in 1978?
Your answer should be compact. 0.51. What is the ratio of the Number of enrolments of both sexes in St. Kitts and Nevis in 1976 to that in 1978?
Offer a terse response. 1.02. What is the ratio of the Number of enrolments of both sexes of Turks and Caicos Islands in 1976 to that in 1978?
Your answer should be compact. 0.94. What is the ratio of the Number of enrolments of both sexes of Cyprus in 1976 to that in 1981?
Provide a succinct answer. 1.04. What is the ratio of the Number of enrolments of both sexes of Guinea-Bissau in 1976 to that in 1981?
Provide a short and direct response. 0.42. What is the ratio of the Number of enrolments of both sexes in St. Kitts and Nevis in 1976 to that in 1981?
Your answer should be very brief. 1.12. What is the ratio of the Number of enrolments of both sexes of Turks and Caicos Islands in 1976 to that in 1981?
Offer a terse response. 0.97. What is the ratio of the Number of enrolments of both sexes in Cyprus in 1976 to that in 1985?
Make the answer very short. 0.96. What is the ratio of the Number of enrolments of both sexes of Guinea-Bissau in 1976 to that in 1985?
Your answer should be very brief. 0.21. What is the ratio of the Number of enrolments of both sexes in St. Kitts and Nevis in 1976 to that in 1985?
Your answer should be very brief. 1.17. What is the ratio of the Number of enrolments of both sexes of Turks and Caicos Islands in 1976 to that in 1985?
Your response must be concise. 0.95. What is the ratio of the Number of enrolments of both sexes in Cyprus in 1976 to that in 2000?
Your answer should be very brief. 0.73. What is the ratio of the Number of enrolments of both sexes of Guinea-Bissau in 1976 to that in 2000?
Provide a short and direct response. 0.07. What is the ratio of the Number of enrolments of both sexes of St. Kitts and Nevis in 1976 to that in 2000?
Offer a terse response. 0.99. What is the ratio of the Number of enrolments of both sexes of Turks and Caicos Islands in 1976 to that in 2000?
Provide a succinct answer. 0.61. What is the ratio of the Number of enrolments of both sexes in Cyprus in 1977 to that in 1978?
Your response must be concise. 1.03. What is the ratio of the Number of enrolments of both sexes of Guinea-Bissau in 1977 to that in 1978?
Provide a short and direct response. 0.83. What is the ratio of the Number of enrolments of both sexes in St. Kitts and Nevis in 1977 to that in 1978?
Offer a very short reply. 1.03. What is the ratio of the Number of enrolments of both sexes in Turks and Caicos Islands in 1977 to that in 1978?
Your answer should be compact. 0.94. What is the ratio of the Number of enrolments of both sexes in Cyprus in 1977 to that in 1981?
Your answer should be very brief. 1.05. What is the ratio of the Number of enrolments of both sexes of Guinea-Bissau in 1977 to that in 1981?
Keep it short and to the point. 0.68. What is the ratio of the Number of enrolments of both sexes in St. Kitts and Nevis in 1977 to that in 1981?
Provide a short and direct response. 1.13. What is the ratio of the Number of enrolments of both sexes of Turks and Caicos Islands in 1977 to that in 1981?
Give a very brief answer. 0.97. What is the ratio of the Number of enrolments of both sexes of Cyprus in 1977 to that in 1985?
Your answer should be very brief. 0.98. What is the ratio of the Number of enrolments of both sexes of Guinea-Bissau in 1977 to that in 1985?
Provide a short and direct response. 0.34. What is the ratio of the Number of enrolments of both sexes in St. Kitts and Nevis in 1977 to that in 1985?
Provide a short and direct response. 1.18. What is the ratio of the Number of enrolments of both sexes in Turks and Caicos Islands in 1977 to that in 1985?
Provide a succinct answer. 0.95. What is the ratio of the Number of enrolments of both sexes of Cyprus in 1977 to that in 2000?
Provide a succinct answer. 0.74. What is the ratio of the Number of enrolments of both sexes of Guinea-Bissau in 1977 to that in 2000?
Ensure brevity in your answer.  0.11. What is the ratio of the Number of enrolments of both sexes in St. Kitts and Nevis in 1977 to that in 2000?
Your answer should be compact. 1. What is the ratio of the Number of enrolments of both sexes in Turks and Caicos Islands in 1977 to that in 2000?
Provide a succinct answer. 0.61. What is the ratio of the Number of enrolments of both sexes of Cyprus in 1978 to that in 1981?
Keep it short and to the point. 1.02. What is the ratio of the Number of enrolments of both sexes of Guinea-Bissau in 1978 to that in 1981?
Keep it short and to the point. 0.83. What is the ratio of the Number of enrolments of both sexes in St. Kitts and Nevis in 1978 to that in 1981?
Offer a terse response. 1.1. What is the ratio of the Number of enrolments of both sexes in Turks and Caicos Islands in 1978 to that in 1981?
Your response must be concise. 1.03. What is the ratio of the Number of enrolments of both sexes in Cyprus in 1978 to that in 1985?
Make the answer very short. 0.95. What is the ratio of the Number of enrolments of both sexes of Guinea-Bissau in 1978 to that in 1985?
Ensure brevity in your answer.  0.41. What is the ratio of the Number of enrolments of both sexes in St. Kitts and Nevis in 1978 to that in 1985?
Provide a succinct answer. 1.15. What is the ratio of the Number of enrolments of both sexes of Turks and Caicos Islands in 1978 to that in 1985?
Make the answer very short. 1.01. What is the ratio of the Number of enrolments of both sexes of Cyprus in 1978 to that in 2000?
Provide a short and direct response. 0.72. What is the ratio of the Number of enrolments of both sexes of Guinea-Bissau in 1978 to that in 2000?
Your answer should be very brief. 0.14. What is the ratio of the Number of enrolments of both sexes in Turks and Caicos Islands in 1978 to that in 2000?
Give a very brief answer. 0.65. What is the ratio of the Number of enrolments of both sexes of Cyprus in 1981 to that in 1985?
Make the answer very short. 0.93. What is the ratio of the Number of enrolments of both sexes of Guinea-Bissau in 1981 to that in 1985?
Your answer should be compact. 0.5. What is the ratio of the Number of enrolments of both sexes of St. Kitts and Nevis in 1981 to that in 1985?
Ensure brevity in your answer.  1.04. What is the ratio of the Number of enrolments of both sexes of Turks and Caicos Islands in 1981 to that in 1985?
Give a very brief answer. 0.98. What is the ratio of the Number of enrolments of both sexes of Cyprus in 1981 to that in 2000?
Give a very brief answer. 0.7. What is the ratio of the Number of enrolments of both sexes of Guinea-Bissau in 1981 to that in 2000?
Offer a terse response. 0.16. What is the ratio of the Number of enrolments of both sexes in St. Kitts and Nevis in 1981 to that in 2000?
Ensure brevity in your answer.  0.88. What is the ratio of the Number of enrolments of both sexes of Turks and Caicos Islands in 1981 to that in 2000?
Make the answer very short. 0.63. What is the ratio of the Number of enrolments of both sexes of Cyprus in 1985 to that in 2000?
Provide a short and direct response. 0.76. What is the ratio of the Number of enrolments of both sexes of Guinea-Bissau in 1985 to that in 2000?
Offer a terse response. 0.33. What is the ratio of the Number of enrolments of both sexes of St. Kitts and Nevis in 1985 to that in 2000?
Your answer should be very brief. 0.85. What is the ratio of the Number of enrolments of both sexes of Turks and Caicos Islands in 1985 to that in 2000?
Ensure brevity in your answer.  0.65. What is the difference between the highest and the second highest Number of enrolments of both sexes of Cyprus?
Your answer should be compact. 1.44e+04. What is the difference between the highest and the second highest Number of enrolments of both sexes in Guinea-Bissau?
Ensure brevity in your answer.  1.68e+04. What is the difference between the highest and the second highest Number of enrolments of both sexes in Turks and Caicos Islands?
Keep it short and to the point. 384. What is the difference between the highest and the lowest Number of enrolments of both sexes in Cyprus?
Your answer should be very brief. 1.75e+04. What is the difference between the highest and the lowest Number of enrolments of both sexes of Guinea-Bissau?
Your answer should be very brief. 2.32e+04. What is the difference between the highest and the lowest Number of enrolments of both sexes in St. Kitts and Nevis?
Ensure brevity in your answer.  732. What is the difference between the highest and the lowest Number of enrolments of both sexes in Turks and Caicos Islands?
Offer a very short reply. 424. 